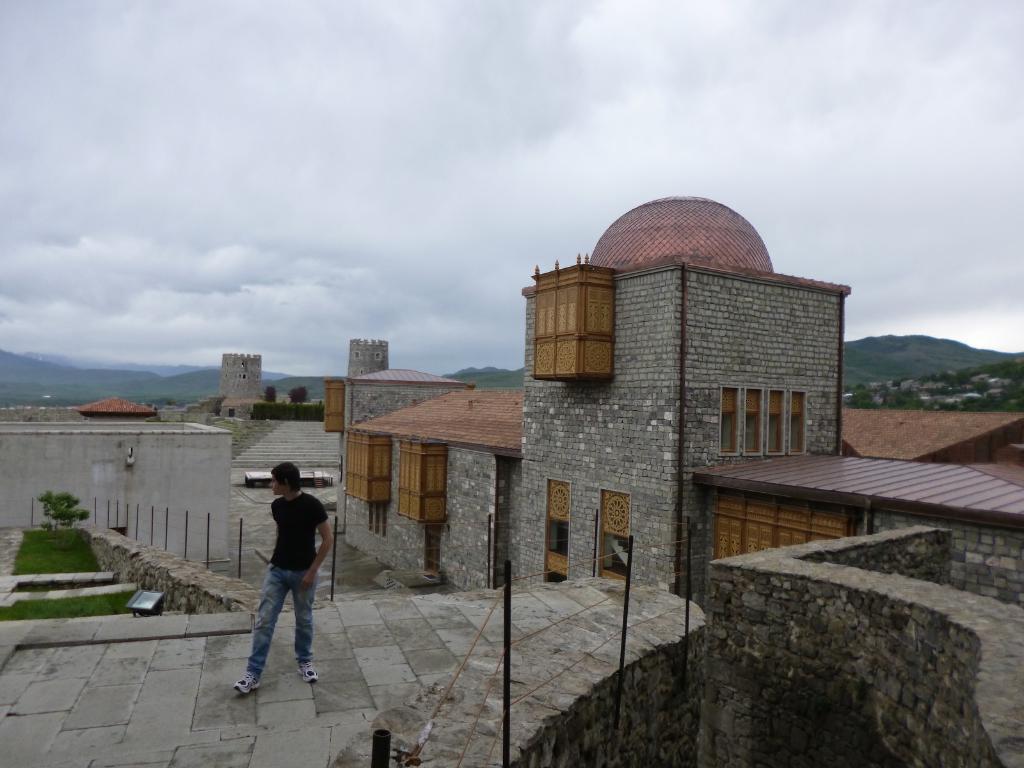Could you give a brief overview of what you see in this image? In this picture I can see the path in front, on which there is a man standing and I see that he is wearing black t-shirt and blue jeans. On the right side of this picture I can see the poles and the wall. In the background I can see few buildings, few more poles, grass, mountains and the cloudy sky. 